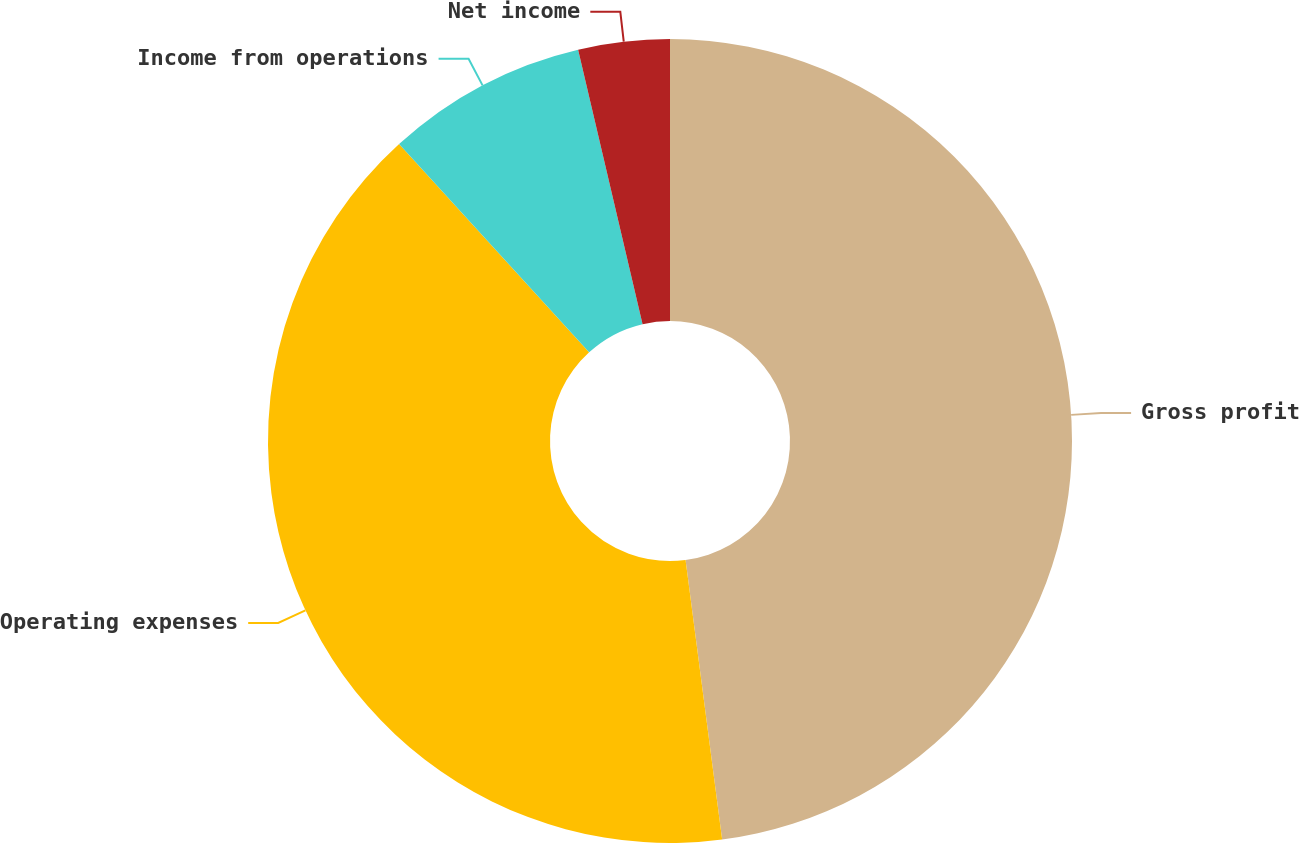<chart> <loc_0><loc_0><loc_500><loc_500><pie_chart><fcel>Gross profit<fcel>Operating expenses<fcel>Income from operations<fcel>Net income<nl><fcel>47.93%<fcel>40.3%<fcel>8.1%<fcel>3.67%<nl></chart> 